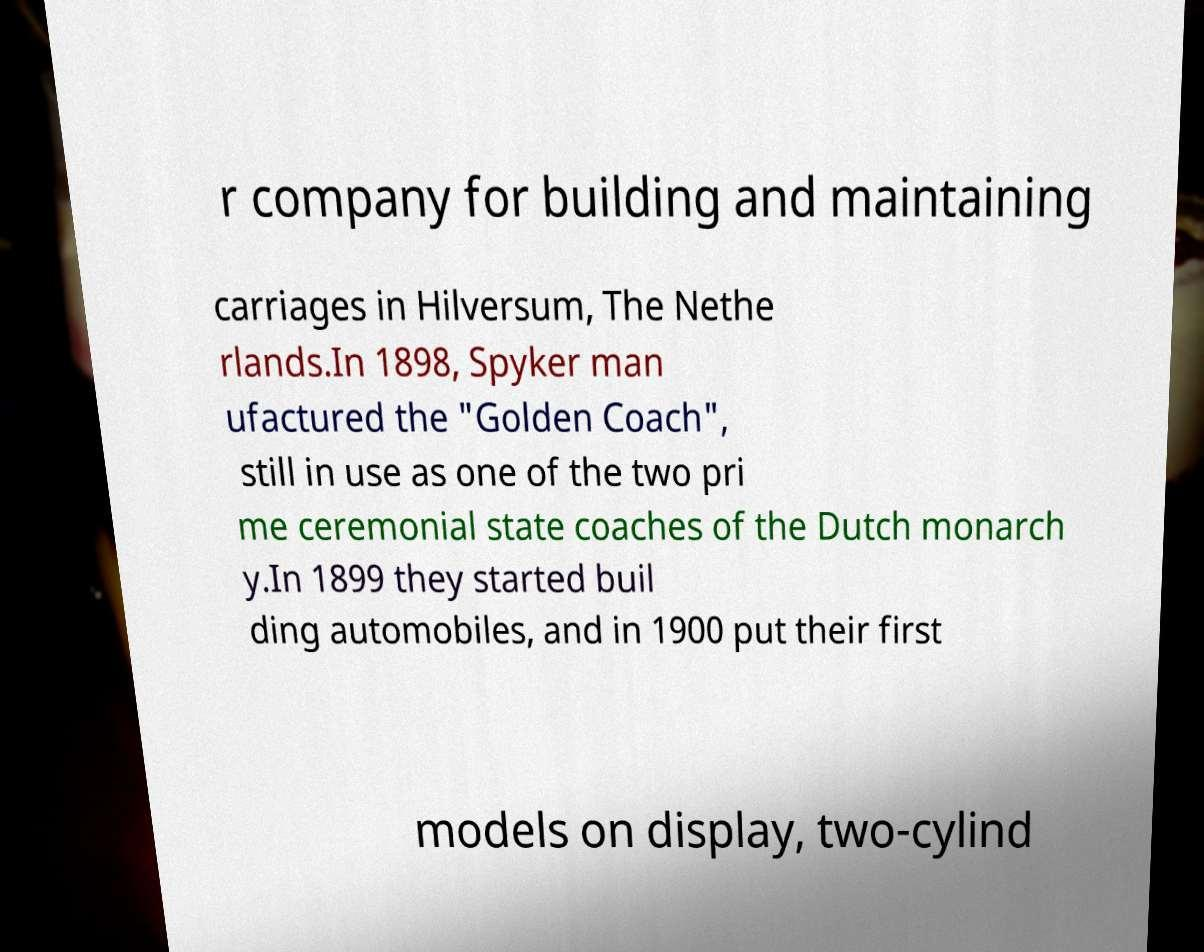For documentation purposes, I need the text within this image transcribed. Could you provide that? r company for building and maintaining carriages in Hilversum, The Nethe rlands.In 1898, Spyker man ufactured the "Golden Coach", still in use as one of the two pri me ceremonial state coaches of the Dutch monarch y.In 1899 they started buil ding automobiles, and in 1900 put their first models on display, two-cylind 